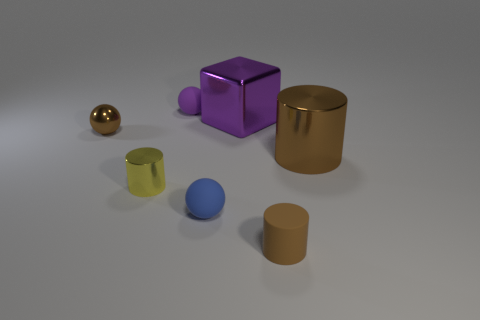Is the small metal ball the same color as the tiny rubber cylinder?
Provide a succinct answer. Yes. What shape is the tiny rubber object to the right of the small rubber ball that is in front of the small shiny cylinder?
Keep it short and to the point. Cylinder. Are there fewer purple matte objects in front of the purple rubber sphere than large shiny cylinders left of the big brown metallic object?
Ensure brevity in your answer.  No. What is the color of the metal thing that is the same shape as the purple matte object?
Provide a succinct answer. Brown. How many brown objects are right of the purple metallic object and behind the brown matte cylinder?
Ensure brevity in your answer.  1. Are there more purple objects behind the big purple metallic cube than yellow objects that are behind the tiny yellow cylinder?
Your answer should be very brief. Yes. What size is the brown metal cylinder?
Your answer should be very brief. Large. Is there a small yellow metal thing that has the same shape as the small brown rubber object?
Keep it short and to the point. Yes. Do the big brown metal thing and the small brown object in front of the small brown ball have the same shape?
Your response must be concise. Yes. What is the size of the matte thing that is both in front of the tiny yellow metallic object and behind the small brown rubber object?
Make the answer very short. Small. 